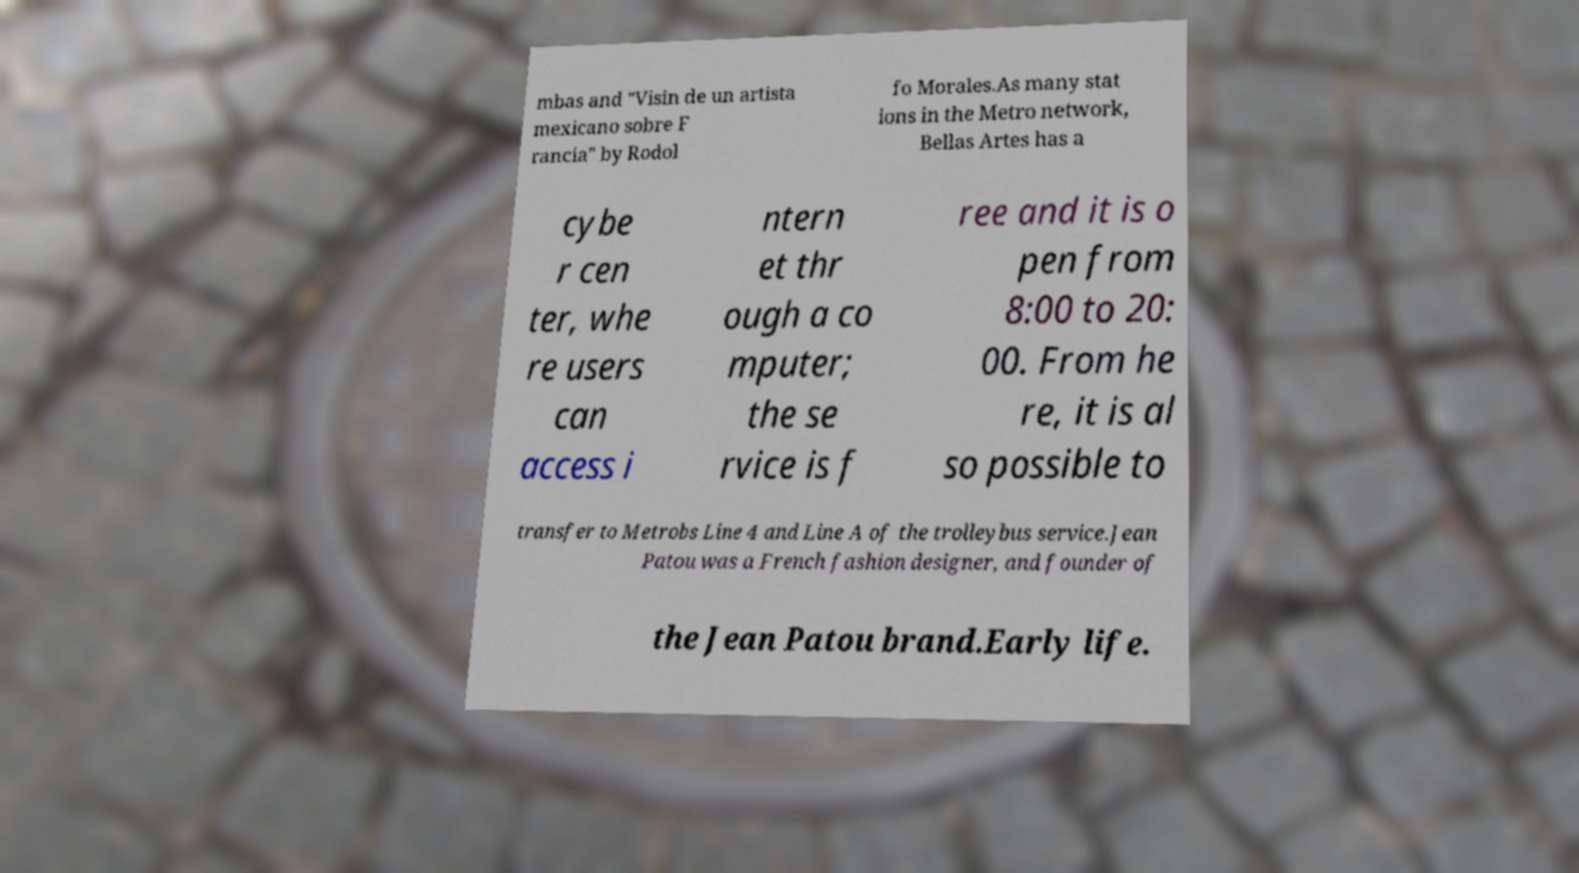Can you accurately transcribe the text from the provided image for me? mbas and "Visin de un artista mexicano sobre F rancia" by Rodol fo Morales.As many stat ions in the Metro network, Bellas Artes has a cybe r cen ter, whe re users can access i ntern et thr ough a co mputer; the se rvice is f ree and it is o pen from 8:00 to 20: 00. From he re, it is al so possible to transfer to Metrobs Line 4 and Line A of the trolleybus service.Jean Patou was a French fashion designer, and founder of the Jean Patou brand.Early life. 